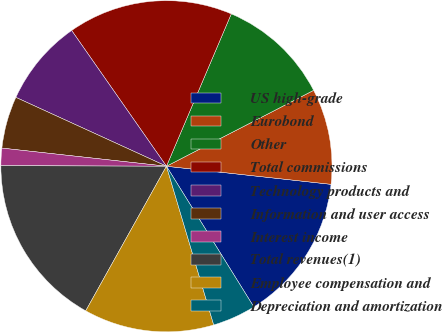Convert chart to OTSL. <chart><loc_0><loc_0><loc_500><loc_500><pie_chart><fcel>US high-grade<fcel>Eurobond<fcel>Other<fcel>Total commissions<fcel>Technology products and<fcel>Information and user access<fcel>Interest income<fcel>Total revenues(1)<fcel>Employee compensation and<fcel>Depreciation and amortization<nl><fcel>14.41%<fcel>9.32%<fcel>11.02%<fcel>16.1%<fcel>8.47%<fcel>5.08%<fcel>1.69%<fcel>16.95%<fcel>12.71%<fcel>4.24%<nl></chart> 